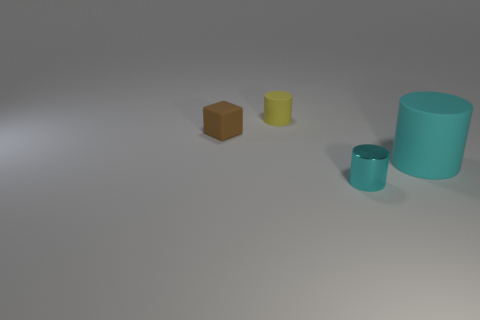Add 1 yellow objects. How many objects exist? 5 Subtract all big cyan cylinders. How many cylinders are left? 2 Subtract all cylinders. How many objects are left? 1 Subtract 2 cylinders. How many cylinders are left? 1 Subtract all green cylinders. Subtract all cyan cubes. How many cylinders are left? 3 Subtract all brown spheres. How many purple cubes are left? 0 Subtract all small things. Subtract all cyan rubber cylinders. How many objects are left? 0 Add 1 brown matte objects. How many brown matte objects are left? 2 Add 2 large cylinders. How many large cylinders exist? 3 Subtract all yellow cylinders. How many cylinders are left? 2 